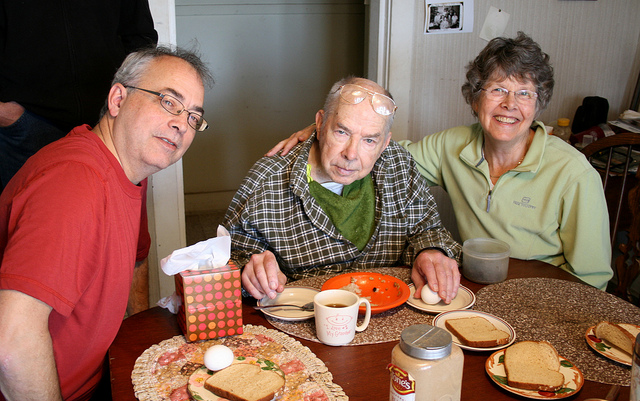<image>Where is the crown? I don't know where the crown is. It is not pictured in the image. What is the pattern of the woman's sweater? The pattern of the woman's sweater is not clear, however, it can be solid or plain. Where is the crown? I don't know where the crown is. It is not pictured in the image. What is the pattern of the woman's sweater? I don't know the pattern of the woman's sweater. It can be either plain or with no pattern. 